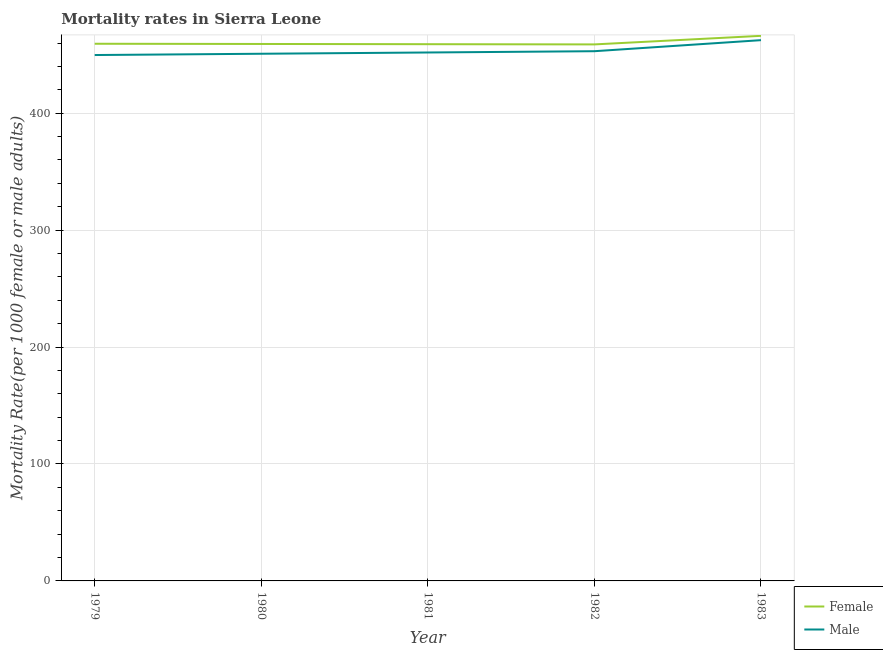Does the line corresponding to male mortality rate intersect with the line corresponding to female mortality rate?
Provide a succinct answer. No. Is the number of lines equal to the number of legend labels?
Your answer should be very brief. Yes. What is the male mortality rate in 1983?
Ensure brevity in your answer.  462.46. Across all years, what is the maximum male mortality rate?
Offer a very short reply. 462.46. Across all years, what is the minimum male mortality rate?
Ensure brevity in your answer.  449.73. In which year was the female mortality rate maximum?
Give a very brief answer. 1983. What is the total female mortality rate in the graph?
Provide a succinct answer. 2302.53. What is the difference between the male mortality rate in 1979 and that in 1983?
Your answer should be compact. -12.72. What is the difference between the male mortality rate in 1983 and the female mortality rate in 1981?
Offer a terse response. 3.45. What is the average male mortality rate per year?
Provide a succinct answer. 453.59. In the year 1980, what is the difference between the female mortality rate and male mortality rate?
Your response must be concise. 8.37. What is the ratio of the female mortality rate in 1979 to that in 1980?
Offer a very short reply. 1. What is the difference between the highest and the second highest male mortality rate?
Provide a short and direct response. 9.46. What is the difference between the highest and the lowest female mortality rate?
Your answer should be very brief. 7.33. Does the female mortality rate monotonically increase over the years?
Make the answer very short. No. How many lines are there?
Provide a short and direct response. 2. How many years are there in the graph?
Ensure brevity in your answer.  5. What is the difference between two consecutive major ticks on the Y-axis?
Your answer should be compact. 100. Are the values on the major ticks of Y-axis written in scientific E-notation?
Keep it short and to the point. No. What is the title of the graph?
Offer a terse response. Mortality rates in Sierra Leone. What is the label or title of the Y-axis?
Your answer should be very brief. Mortality Rate(per 1000 female or male adults). What is the Mortality Rate(per 1000 female or male adults) in Female in 1979?
Your answer should be compact. 459.38. What is the Mortality Rate(per 1000 female or male adults) in Male in 1979?
Offer a very short reply. 449.73. What is the Mortality Rate(per 1000 female or male adults) of Female in 1980?
Ensure brevity in your answer.  459.19. What is the Mortality Rate(per 1000 female or male adults) of Male in 1980?
Give a very brief answer. 450.82. What is the Mortality Rate(per 1000 female or male adults) in Female in 1981?
Your response must be concise. 459. What is the Mortality Rate(per 1000 female or male adults) in Male in 1981?
Your answer should be compact. 451.91. What is the Mortality Rate(per 1000 female or male adults) in Female in 1982?
Make the answer very short. 458.81. What is the Mortality Rate(per 1000 female or male adults) in Male in 1982?
Keep it short and to the point. 453. What is the Mortality Rate(per 1000 female or male adults) in Female in 1983?
Provide a short and direct response. 466.15. What is the Mortality Rate(per 1000 female or male adults) in Male in 1983?
Offer a very short reply. 462.46. Across all years, what is the maximum Mortality Rate(per 1000 female or male adults) in Female?
Offer a very short reply. 466.15. Across all years, what is the maximum Mortality Rate(per 1000 female or male adults) of Male?
Provide a succinct answer. 462.46. Across all years, what is the minimum Mortality Rate(per 1000 female or male adults) in Female?
Your response must be concise. 458.81. Across all years, what is the minimum Mortality Rate(per 1000 female or male adults) in Male?
Your response must be concise. 449.73. What is the total Mortality Rate(per 1000 female or male adults) in Female in the graph?
Make the answer very short. 2302.53. What is the total Mortality Rate(per 1000 female or male adults) of Male in the graph?
Your response must be concise. 2267.93. What is the difference between the Mortality Rate(per 1000 female or male adults) in Female in 1979 and that in 1980?
Provide a short and direct response. 0.19. What is the difference between the Mortality Rate(per 1000 female or male adults) in Male in 1979 and that in 1980?
Keep it short and to the point. -1.09. What is the difference between the Mortality Rate(per 1000 female or male adults) in Female in 1979 and that in 1981?
Offer a very short reply. 0.38. What is the difference between the Mortality Rate(per 1000 female or male adults) of Male in 1979 and that in 1981?
Make the answer very short. -2.18. What is the difference between the Mortality Rate(per 1000 female or male adults) of Female in 1979 and that in 1982?
Make the answer very short. 0.57. What is the difference between the Mortality Rate(per 1000 female or male adults) in Male in 1979 and that in 1982?
Your response must be concise. -3.27. What is the difference between the Mortality Rate(per 1000 female or male adults) of Female in 1979 and that in 1983?
Offer a very short reply. -6.77. What is the difference between the Mortality Rate(per 1000 female or male adults) in Male in 1979 and that in 1983?
Keep it short and to the point. -12.72. What is the difference between the Mortality Rate(per 1000 female or male adults) in Female in 1980 and that in 1981?
Ensure brevity in your answer.  0.19. What is the difference between the Mortality Rate(per 1000 female or male adults) of Male in 1980 and that in 1981?
Give a very brief answer. -1.09. What is the difference between the Mortality Rate(per 1000 female or male adults) of Female in 1980 and that in 1982?
Keep it short and to the point. 0.38. What is the difference between the Mortality Rate(per 1000 female or male adults) of Male in 1980 and that in 1982?
Ensure brevity in your answer.  -2.18. What is the difference between the Mortality Rate(per 1000 female or male adults) in Female in 1980 and that in 1983?
Offer a very short reply. -6.96. What is the difference between the Mortality Rate(per 1000 female or male adults) of Male in 1980 and that in 1983?
Your answer should be very brief. -11.63. What is the difference between the Mortality Rate(per 1000 female or male adults) of Female in 1981 and that in 1982?
Keep it short and to the point. 0.19. What is the difference between the Mortality Rate(per 1000 female or male adults) in Male in 1981 and that in 1982?
Offer a terse response. -1.09. What is the difference between the Mortality Rate(per 1000 female or male adults) of Female in 1981 and that in 1983?
Provide a short and direct response. -7.14. What is the difference between the Mortality Rate(per 1000 female or male adults) of Male in 1981 and that in 1983?
Offer a terse response. -10.54. What is the difference between the Mortality Rate(per 1000 female or male adults) in Female in 1982 and that in 1983?
Offer a very short reply. -7.33. What is the difference between the Mortality Rate(per 1000 female or male adults) in Male in 1982 and that in 1983?
Your response must be concise. -9.46. What is the difference between the Mortality Rate(per 1000 female or male adults) of Female in 1979 and the Mortality Rate(per 1000 female or male adults) of Male in 1980?
Offer a very short reply. 8.56. What is the difference between the Mortality Rate(per 1000 female or male adults) in Female in 1979 and the Mortality Rate(per 1000 female or male adults) in Male in 1981?
Provide a short and direct response. 7.47. What is the difference between the Mortality Rate(per 1000 female or male adults) of Female in 1979 and the Mortality Rate(per 1000 female or male adults) of Male in 1982?
Your answer should be very brief. 6.38. What is the difference between the Mortality Rate(per 1000 female or male adults) in Female in 1979 and the Mortality Rate(per 1000 female or male adults) in Male in 1983?
Make the answer very short. -3.08. What is the difference between the Mortality Rate(per 1000 female or male adults) of Female in 1980 and the Mortality Rate(per 1000 female or male adults) of Male in 1981?
Your response must be concise. 7.28. What is the difference between the Mortality Rate(per 1000 female or male adults) of Female in 1980 and the Mortality Rate(per 1000 female or male adults) of Male in 1982?
Provide a succinct answer. 6.19. What is the difference between the Mortality Rate(per 1000 female or male adults) in Female in 1980 and the Mortality Rate(per 1000 female or male adults) in Male in 1983?
Provide a short and direct response. -3.27. What is the difference between the Mortality Rate(per 1000 female or male adults) of Female in 1981 and the Mortality Rate(per 1000 female or male adults) of Male in 1982?
Provide a short and direct response. 6. What is the difference between the Mortality Rate(per 1000 female or male adults) in Female in 1981 and the Mortality Rate(per 1000 female or male adults) in Male in 1983?
Give a very brief answer. -3.45. What is the difference between the Mortality Rate(per 1000 female or male adults) of Female in 1982 and the Mortality Rate(per 1000 female or male adults) of Male in 1983?
Keep it short and to the point. -3.64. What is the average Mortality Rate(per 1000 female or male adults) of Female per year?
Ensure brevity in your answer.  460.51. What is the average Mortality Rate(per 1000 female or male adults) of Male per year?
Keep it short and to the point. 453.58. In the year 1979, what is the difference between the Mortality Rate(per 1000 female or male adults) in Female and Mortality Rate(per 1000 female or male adults) in Male?
Make the answer very short. 9.65. In the year 1980, what is the difference between the Mortality Rate(per 1000 female or male adults) of Female and Mortality Rate(per 1000 female or male adults) of Male?
Offer a very short reply. 8.37. In the year 1981, what is the difference between the Mortality Rate(per 1000 female or male adults) of Female and Mortality Rate(per 1000 female or male adults) of Male?
Provide a succinct answer. 7.09. In the year 1982, what is the difference between the Mortality Rate(per 1000 female or male adults) of Female and Mortality Rate(per 1000 female or male adults) of Male?
Provide a short and direct response. 5.81. In the year 1983, what is the difference between the Mortality Rate(per 1000 female or male adults) of Female and Mortality Rate(per 1000 female or male adults) of Male?
Provide a succinct answer. 3.69. What is the ratio of the Mortality Rate(per 1000 female or male adults) in Male in 1979 to that in 1980?
Ensure brevity in your answer.  1. What is the ratio of the Mortality Rate(per 1000 female or male adults) of Male in 1979 to that in 1981?
Provide a short and direct response. 1. What is the ratio of the Mortality Rate(per 1000 female or male adults) in Female in 1979 to that in 1983?
Provide a short and direct response. 0.99. What is the ratio of the Mortality Rate(per 1000 female or male adults) of Male in 1979 to that in 1983?
Your response must be concise. 0.97. What is the ratio of the Mortality Rate(per 1000 female or male adults) in Male in 1980 to that in 1981?
Your answer should be very brief. 1. What is the ratio of the Mortality Rate(per 1000 female or male adults) of Female in 1980 to that in 1982?
Provide a succinct answer. 1. What is the ratio of the Mortality Rate(per 1000 female or male adults) of Female in 1980 to that in 1983?
Your response must be concise. 0.99. What is the ratio of the Mortality Rate(per 1000 female or male adults) of Male in 1980 to that in 1983?
Keep it short and to the point. 0.97. What is the ratio of the Mortality Rate(per 1000 female or male adults) in Female in 1981 to that in 1983?
Your response must be concise. 0.98. What is the ratio of the Mortality Rate(per 1000 female or male adults) of Male in 1981 to that in 1983?
Offer a very short reply. 0.98. What is the ratio of the Mortality Rate(per 1000 female or male adults) in Female in 1982 to that in 1983?
Give a very brief answer. 0.98. What is the ratio of the Mortality Rate(per 1000 female or male adults) in Male in 1982 to that in 1983?
Provide a short and direct response. 0.98. What is the difference between the highest and the second highest Mortality Rate(per 1000 female or male adults) of Female?
Provide a short and direct response. 6.77. What is the difference between the highest and the second highest Mortality Rate(per 1000 female or male adults) in Male?
Keep it short and to the point. 9.46. What is the difference between the highest and the lowest Mortality Rate(per 1000 female or male adults) of Female?
Your answer should be compact. 7.33. What is the difference between the highest and the lowest Mortality Rate(per 1000 female or male adults) in Male?
Provide a succinct answer. 12.72. 